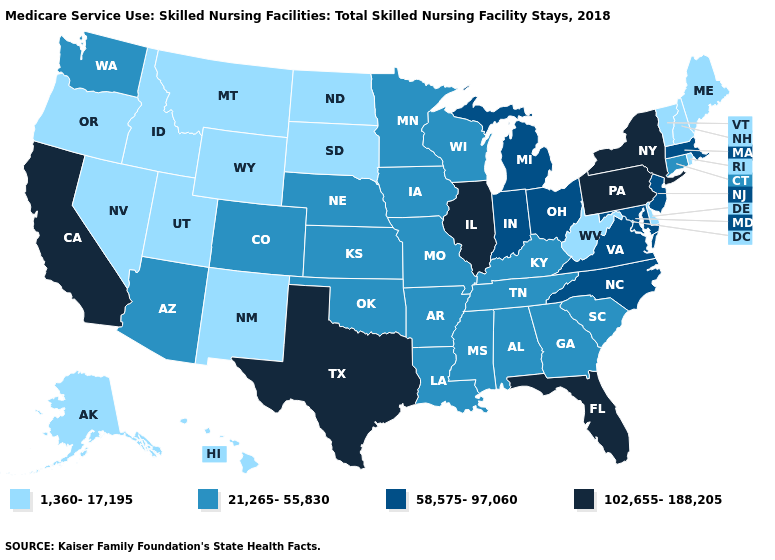What is the value of Utah?
Short answer required. 1,360-17,195. How many symbols are there in the legend?
Give a very brief answer. 4. What is the value of Alabama?
Write a very short answer. 21,265-55,830. What is the value of Iowa?
Keep it brief. 21,265-55,830. Which states have the lowest value in the USA?
Concise answer only. Alaska, Delaware, Hawaii, Idaho, Maine, Montana, Nevada, New Hampshire, New Mexico, North Dakota, Oregon, Rhode Island, South Dakota, Utah, Vermont, West Virginia, Wyoming. What is the value of Maine?
Quick response, please. 1,360-17,195. Does Maryland have a lower value than Texas?
Be succinct. Yes. Name the states that have a value in the range 58,575-97,060?
Give a very brief answer. Indiana, Maryland, Massachusetts, Michigan, New Jersey, North Carolina, Ohio, Virginia. What is the lowest value in the South?
Write a very short answer. 1,360-17,195. What is the highest value in states that border Minnesota?
Answer briefly. 21,265-55,830. Does Nebraska have the same value as Vermont?
Keep it brief. No. What is the value of Oklahoma?
Write a very short answer. 21,265-55,830. Among the states that border Colorado , which have the lowest value?
Write a very short answer. New Mexico, Utah, Wyoming. Is the legend a continuous bar?
Quick response, please. No. Does North Dakota have the lowest value in the USA?
Be succinct. Yes. 